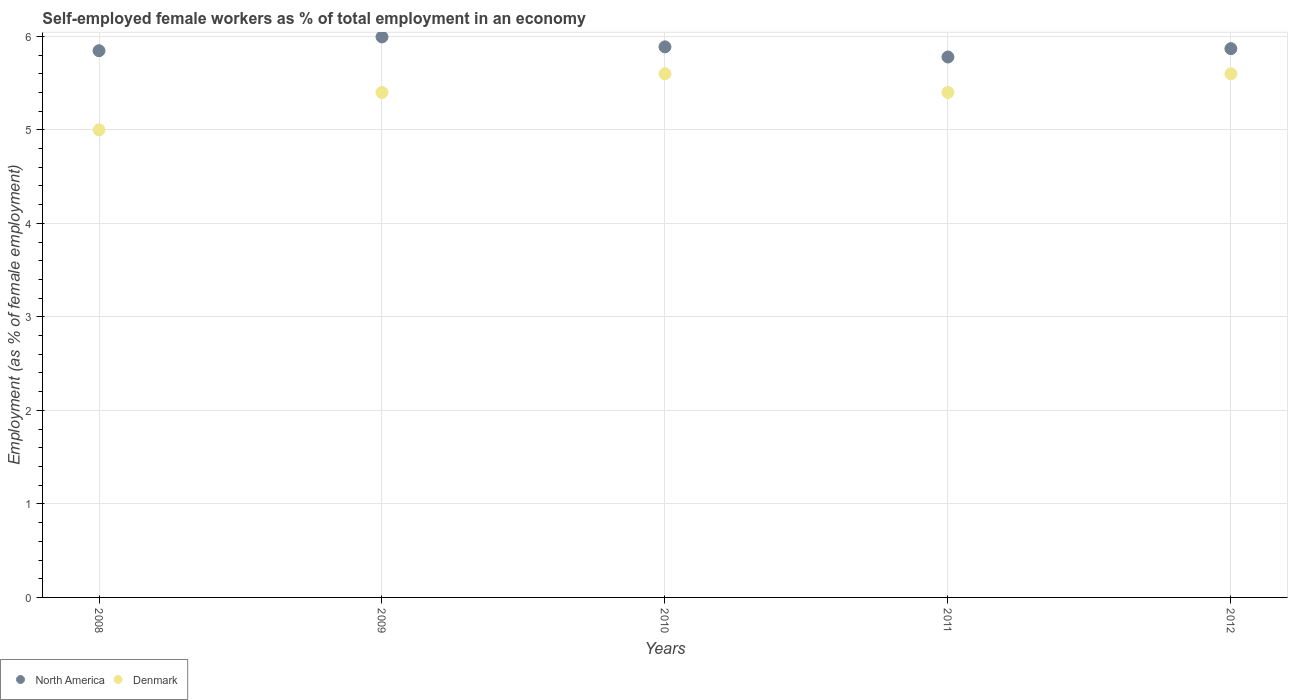How many different coloured dotlines are there?
Make the answer very short. 2. What is the percentage of self-employed female workers in Denmark in 2009?
Your answer should be compact. 5.4. Across all years, what is the maximum percentage of self-employed female workers in Denmark?
Your answer should be very brief. 5.6. Across all years, what is the minimum percentage of self-employed female workers in North America?
Ensure brevity in your answer.  5.78. In which year was the percentage of self-employed female workers in North America minimum?
Your answer should be very brief. 2011. What is the difference between the percentage of self-employed female workers in North America in 2008 and that in 2011?
Offer a very short reply. 0.07. What is the difference between the percentage of self-employed female workers in North America in 2011 and the percentage of self-employed female workers in Denmark in 2010?
Keep it short and to the point. 0.18. In the year 2010, what is the difference between the percentage of self-employed female workers in North America and percentage of self-employed female workers in Denmark?
Your answer should be very brief. 0.29. What is the ratio of the percentage of self-employed female workers in North America in 2009 to that in 2010?
Ensure brevity in your answer.  1.02. What is the difference between the highest and the lowest percentage of self-employed female workers in Denmark?
Keep it short and to the point. 0.6. Is the sum of the percentage of self-employed female workers in Denmark in 2009 and 2012 greater than the maximum percentage of self-employed female workers in North America across all years?
Keep it short and to the point. Yes. Does the percentage of self-employed female workers in Denmark monotonically increase over the years?
Your response must be concise. No. Is the percentage of self-employed female workers in North America strictly greater than the percentage of self-employed female workers in Denmark over the years?
Give a very brief answer. Yes. Is the percentage of self-employed female workers in North America strictly less than the percentage of self-employed female workers in Denmark over the years?
Give a very brief answer. No. How many years are there in the graph?
Give a very brief answer. 5. Does the graph contain grids?
Provide a succinct answer. Yes. Where does the legend appear in the graph?
Your response must be concise. Bottom left. How many legend labels are there?
Your response must be concise. 2. How are the legend labels stacked?
Give a very brief answer. Horizontal. What is the title of the graph?
Make the answer very short. Self-employed female workers as % of total employment in an economy. Does "Dominican Republic" appear as one of the legend labels in the graph?
Make the answer very short. No. What is the label or title of the X-axis?
Make the answer very short. Years. What is the label or title of the Y-axis?
Your answer should be compact. Employment (as % of female employment). What is the Employment (as % of female employment) in North America in 2008?
Give a very brief answer. 5.85. What is the Employment (as % of female employment) in North America in 2009?
Give a very brief answer. 5.99. What is the Employment (as % of female employment) of Denmark in 2009?
Your response must be concise. 5.4. What is the Employment (as % of female employment) in North America in 2010?
Provide a short and direct response. 5.89. What is the Employment (as % of female employment) of Denmark in 2010?
Keep it short and to the point. 5.6. What is the Employment (as % of female employment) of North America in 2011?
Provide a short and direct response. 5.78. What is the Employment (as % of female employment) of Denmark in 2011?
Provide a succinct answer. 5.4. What is the Employment (as % of female employment) in North America in 2012?
Offer a very short reply. 5.87. What is the Employment (as % of female employment) in Denmark in 2012?
Offer a very short reply. 5.6. Across all years, what is the maximum Employment (as % of female employment) in North America?
Your response must be concise. 5.99. Across all years, what is the maximum Employment (as % of female employment) of Denmark?
Keep it short and to the point. 5.6. Across all years, what is the minimum Employment (as % of female employment) in North America?
Your response must be concise. 5.78. Across all years, what is the minimum Employment (as % of female employment) in Denmark?
Your answer should be very brief. 5. What is the total Employment (as % of female employment) in North America in the graph?
Ensure brevity in your answer.  29.38. What is the difference between the Employment (as % of female employment) of North America in 2008 and that in 2009?
Provide a short and direct response. -0.15. What is the difference between the Employment (as % of female employment) in Denmark in 2008 and that in 2009?
Give a very brief answer. -0.4. What is the difference between the Employment (as % of female employment) of North America in 2008 and that in 2010?
Make the answer very short. -0.04. What is the difference between the Employment (as % of female employment) in Denmark in 2008 and that in 2010?
Ensure brevity in your answer.  -0.6. What is the difference between the Employment (as % of female employment) in North America in 2008 and that in 2011?
Your answer should be very brief. 0.07. What is the difference between the Employment (as % of female employment) of North America in 2008 and that in 2012?
Ensure brevity in your answer.  -0.02. What is the difference between the Employment (as % of female employment) in Denmark in 2008 and that in 2012?
Your response must be concise. -0.6. What is the difference between the Employment (as % of female employment) in North America in 2009 and that in 2010?
Provide a succinct answer. 0.11. What is the difference between the Employment (as % of female employment) of Denmark in 2009 and that in 2010?
Offer a very short reply. -0.2. What is the difference between the Employment (as % of female employment) of North America in 2009 and that in 2011?
Keep it short and to the point. 0.21. What is the difference between the Employment (as % of female employment) of Denmark in 2009 and that in 2011?
Offer a terse response. 0. What is the difference between the Employment (as % of female employment) in North America in 2009 and that in 2012?
Offer a very short reply. 0.13. What is the difference between the Employment (as % of female employment) of North America in 2010 and that in 2011?
Provide a short and direct response. 0.11. What is the difference between the Employment (as % of female employment) of North America in 2010 and that in 2012?
Your answer should be compact. 0.02. What is the difference between the Employment (as % of female employment) in Denmark in 2010 and that in 2012?
Your answer should be compact. 0. What is the difference between the Employment (as % of female employment) in North America in 2011 and that in 2012?
Your response must be concise. -0.09. What is the difference between the Employment (as % of female employment) in Denmark in 2011 and that in 2012?
Keep it short and to the point. -0.2. What is the difference between the Employment (as % of female employment) in North America in 2008 and the Employment (as % of female employment) in Denmark in 2009?
Provide a succinct answer. 0.45. What is the difference between the Employment (as % of female employment) in North America in 2008 and the Employment (as % of female employment) in Denmark in 2010?
Ensure brevity in your answer.  0.25. What is the difference between the Employment (as % of female employment) in North America in 2008 and the Employment (as % of female employment) in Denmark in 2011?
Your response must be concise. 0.45. What is the difference between the Employment (as % of female employment) in North America in 2008 and the Employment (as % of female employment) in Denmark in 2012?
Keep it short and to the point. 0.25. What is the difference between the Employment (as % of female employment) of North America in 2009 and the Employment (as % of female employment) of Denmark in 2010?
Provide a short and direct response. 0.39. What is the difference between the Employment (as % of female employment) of North America in 2009 and the Employment (as % of female employment) of Denmark in 2011?
Ensure brevity in your answer.  0.59. What is the difference between the Employment (as % of female employment) of North America in 2009 and the Employment (as % of female employment) of Denmark in 2012?
Offer a terse response. 0.39. What is the difference between the Employment (as % of female employment) in North America in 2010 and the Employment (as % of female employment) in Denmark in 2011?
Give a very brief answer. 0.49. What is the difference between the Employment (as % of female employment) in North America in 2010 and the Employment (as % of female employment) in Denmark in 2012?
Offer a very short reply. 0.29. What is the difference between the Employment (as % of female employment) in North America in 2011 and the Employment (as % of female employment) in Denmark in 2012?
Make the answer very short. 0.18. What is the average Employment (as % of female employment) of North America per year?
Your answer should be very brief. 5.88. What is the average Employment (as % of female employment) in Denmark per year?
Your response must be concise. 5.4. In the year 2008, what is the difference between the Employment (as % of female employment) of North America and Employment (as % of female employment) of Denmark?
Make the answer very short. 0.85. In the year 2009, what is the difference between the Employment (as % of female employment) of North America and Employment (as % of female employment) of Denmark?
Give a very brief answer. 0.59. In the year 2010, what is the difference between the Employment (as % of female employment) in North America and Employment (as % of female employment) in Denmark?
Offer a terse response. 0.29. In the year 2011, what is the difference between the Employment (as % of female employment) in North America and Employment (as % of female employment) in Denmark?
Your response must be concise. 0.38. In the year 2012, what is the difference between the Employment (as % of female employment) in North America and Employment (as % of female employment) in Denmark?
Ensure brevity in your answer.  0.27. What is the ratio of the Employment (as % of female employment) in North America in 2008 to that in 2009?
Make the answer very short. 0.98. What is the ratio of the Employment (as % of female employment) of Denmark in 2008 to that in 2009?
Offer a very short reply. 0.93. What is the ratio of the Employment (as % of female employment) in Denmark in 2008 to that in 2010?
Provide a short and direct response. 0.89. What is the ratio of the Employment (as % of female employment) of North America in 2008 to that in 2011?
Your answer should be very brief. 1.01. What is the ratio of the Employment (as % of female employment) in Denmark in 2008 to that in 2011?
Provide a short and direct response. 0.93. What is the ratio of the Employment (as % of female employment) in Denmark in 2008 to that in 2012?
Your answer should be very brief. 0.89. What is the ratio of the Employment (as % of female employment) in North America in 2009 to that in 2010?
Your answer should be very brief. 1.02. What is the ratio of the Employment (as % of female employment) of Denmark in 2009 to that in 2010?
Offer a very short reply. 0.96. What is the ratio of the Employment (as % of female employment) in North America in 2009 to that in 2011?
Your response must be concise. 1.04. What is the ratio of the Employment (as % of female employment) in North America in 2009 to that in 2012?
Offer a very short reply. 1.02. What is the ratio of the Employment (as % of female employment) of North America in 2010 to that in 2011?
Keep it short and to the point. 1.02. What is the ratio of the Employment (as % of female employment) of Denmark in 2010 to that in 2011?
Your answer should be very brief. 1.04. What is the ratio of the Employment (as % of female employment) in North America in 2010 to that in 2012?
Your response must be concise. 1. What is the ratio of the Employment (as % of female employment) of Denmark in 2011 to that in 2012?
Give a very brief answer. 0.96. What is the difference between the highest and the second highest Employment (as % of female employment) in North America?
Your response must be concise. 0.11. What is the difference between the highest and the lowest Employment (as % of female employment) of North America?
Your response must be concise. 0.21. 